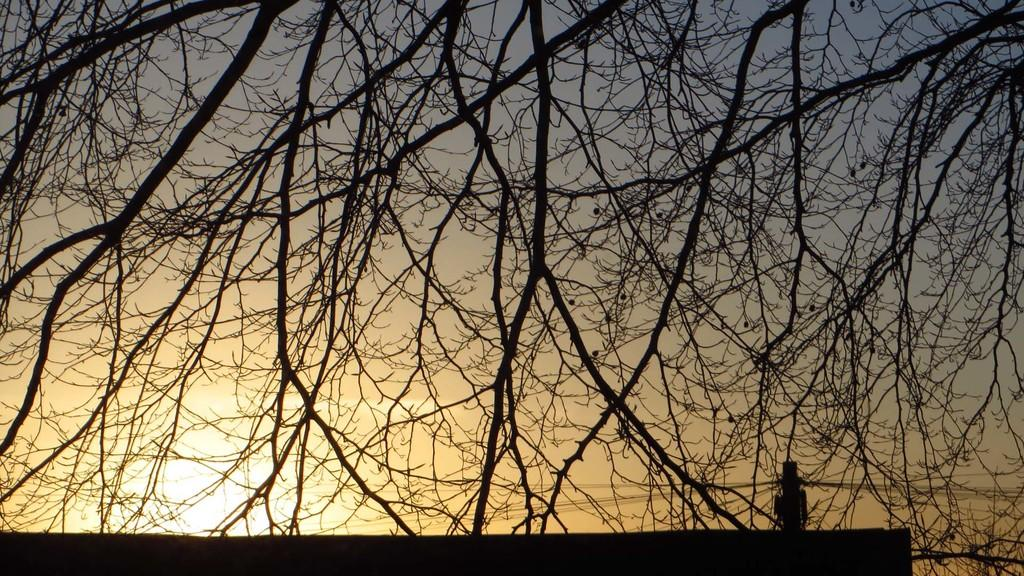What type of vegetation can be seen in the image? There are branches of trees in the image. What is visible behind the branches? The sky is visible behind the branches. What type of seat can be seen on the branches of the trees in the image? There are no seats present on the branches of the trees in the image. 